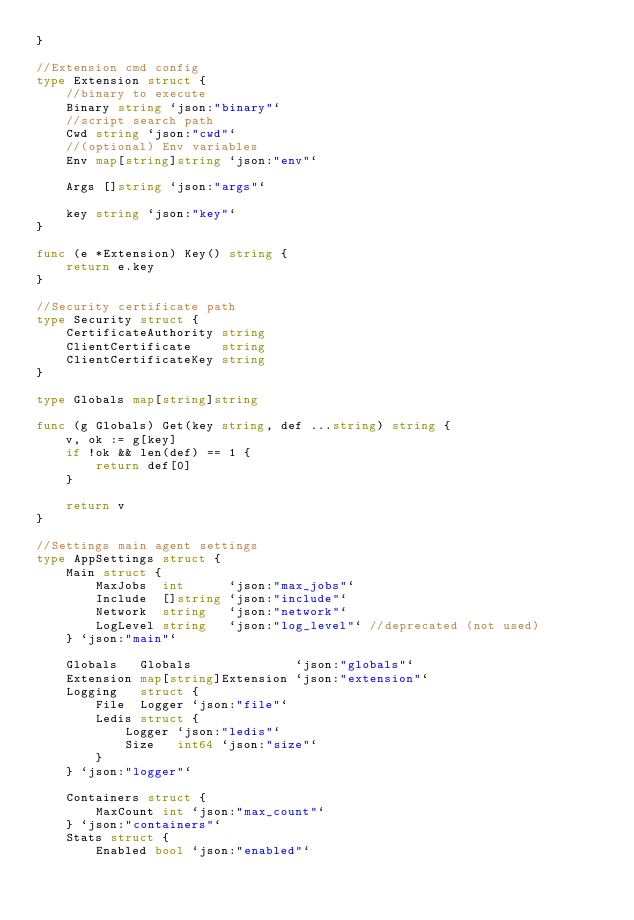<code> <loc_0><loc_0><loc_500><loc_500><_Go_>}

//Extension cmd config
type Extension struct {
	//binary to execute
	Binary string `json:"binary"`
	//script search path
	Cwd string `json:"cwd"`
	//(optional) Env variables
	Env map[string]string `json:"env"`

	Args []string `json:"args"`

	key string `json:"key"`
}

func (e *Extension) Key() string {
	return e.key
}

//Security certificate path
type Security struct {
	CertificateAuthority string
	ClientCertificate    string
	ClientCertificateKey string
}

type Globals map[string]string

func (g Globals) Get(key string, def ...string) string {
	v, ok := g[key]
	if !ok && len(def) == 1 {
		return def[0]
	}

	return v
}

//Settings main agent settings
type AppSettings struct {
	Main struct {
		MaxJobs  int      `json:"max_jobs"`
		Include  []string `json:"include"`
		Network  string   `json:"network"`
		LogLevel string   `json:"log_level"` //deprecated (not used)
	} `json:"main"`

	Globals   Globals              `json:"globals"`
	Extension map[string]Extension `json:"extension"`
	Logging   struct {
		File  Logger `json:"file"`
		Ledis struct {
			Logger `json:"ledis"`
			Size   int64 `json:"size"`
		}
	} `json:"logger"`

	Containers struct {
		MaxCount int `json:"max_count"`
	} `json:"containers"`
	Stats struct {
		Enabled bool `json:"enabled"`</code> 